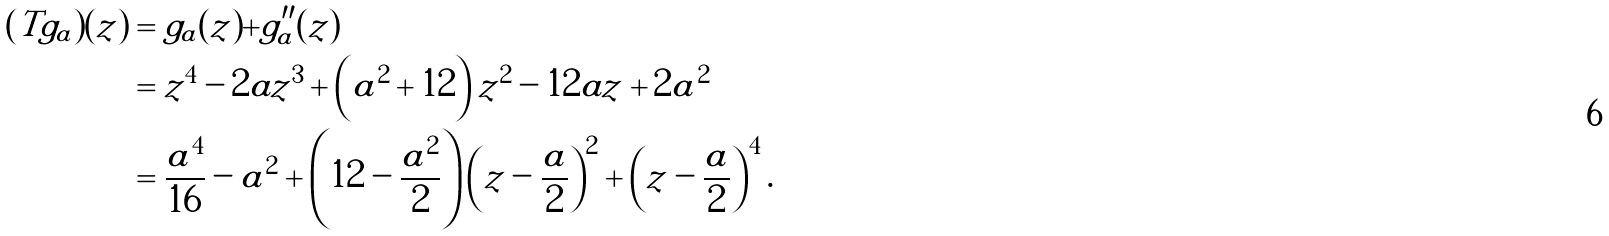Convert formula to latex. <formula><loc_0><loc_0><loc_500><loc_500>( T g _ { a } ) ( z ) & = g _ { a } ( z ) + g _ { a } ^ { \prime \prime } ( z ) \\ & = z ^ { 4 } - 2 a z ^ { 3 } + \left ( a ^ { 2 } + 1 2 \right ) z ^ { 2 } - 1 2 a z + 2 a ^ { 2 } \\ & = \frac { a ^ { 4 } } { 1 6 } - a ^ { 2 } + \left ( 1 2 - \frac { a ^ { 2 } } { 2 } \right ) \left ( z - \frac { a } { 2 } \right ) ^ { 2 } + \left ( z - \frac { a } { 2 } \right ) ^ { 4 } .</formula> 